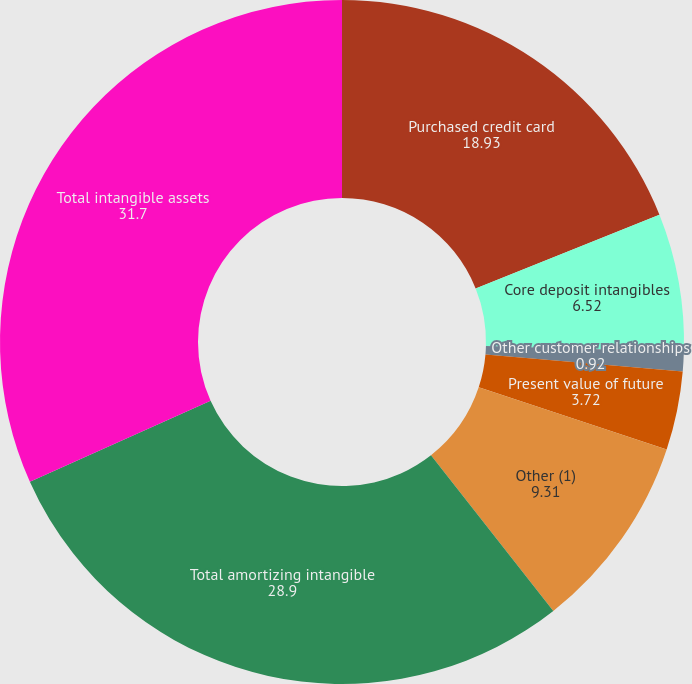Convert chart. <chart><loc_0><loc_0><loc_500><loc_500><pie_chart><fcel>Purchased credit card<fcel>Core deposit intangibles<fcel>Other customer relationships<fcel>Present value of future<fcel>Other (1)<fcel>Total amortizing intangible<fcel>Total intangible assets<nl><fcel>18.93%<fcel>6.52%<fcel>0.92%<fcel>3.72%<fcel>9.31%<fcel>28.9%<fcel>31.7%<nl></chart> 